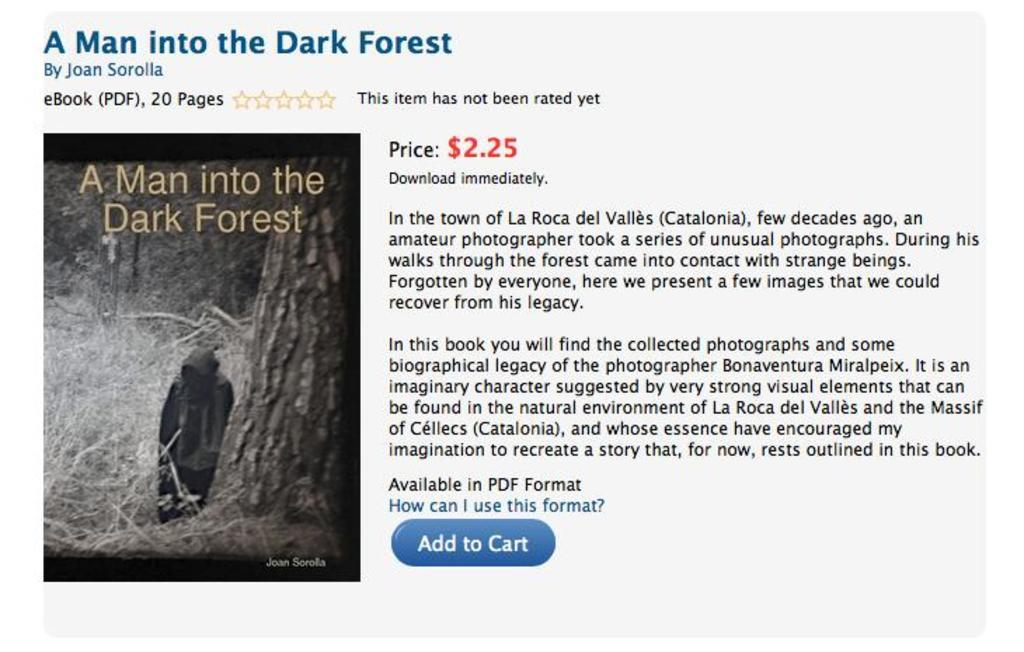What is the main subject of the picture? The picture contains an image of a man in a dark forest. What can be found beside the image? There is text written beside the image. What is located above the image? There is text written above the image. How many bears are visible in the image? There are no bears present in the image; it depicts a man in a dark forest. What is the rate of snake movement in the image? There are no snakes present in the image, so it is not possible to determine their rate of movement. 